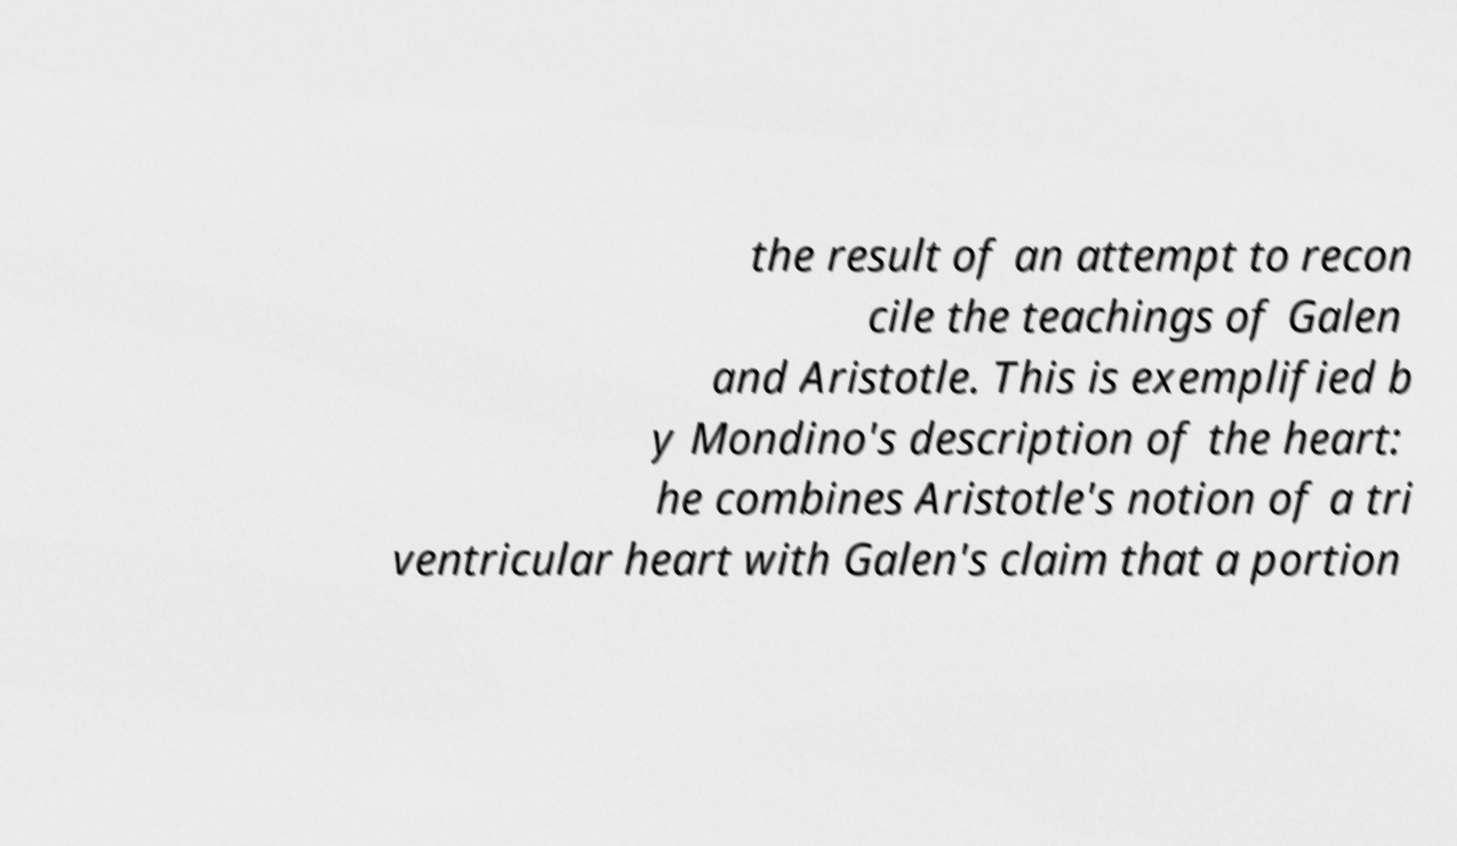For documentation purposes, I need the text within this image transcribed. Could you provide that? the result of an attempt to recon cile the teachings of Galen and Aristotle. This is exemplified b y Mondino's description of the heart: he combines Aristotle's notion of a tri ventricular heart with Galen's claim that a portion 